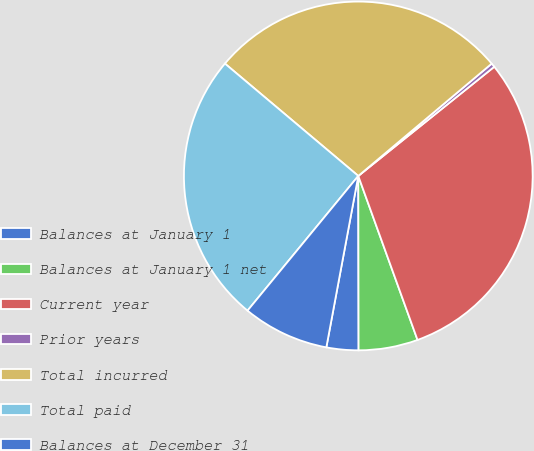Convert chart. <chart><loc_0><loc_0><loc_500><loc_500><pie_chart><fcel>Balances at January 1<fcel>Balances at January 1 net<fcel>Current year<fcel>Prior years<fcel>Total incurred<fcel>Total paid<fcel>Balances at December 31<nl><fcel>2.96%<fcel>5.49%<fcel>30.25%<fcel>0.37%<fcel>27.72%<fcel>25.19%<fcel>8.02%<nl></chart> 